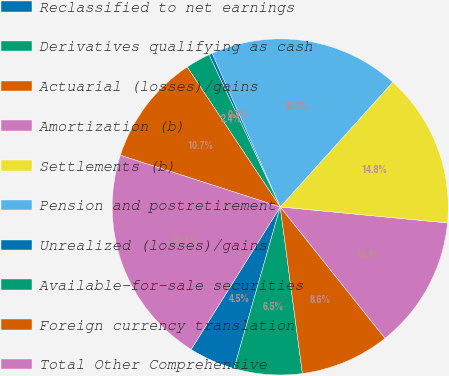Convert chart. <chart><loc_0><loc_0><loc_500><loc_500><pie_chart><fcel>Reclassified to net earnings<fcel>Derivatives qualifying as cash<fcel>Actuarial (losses)/gains<fcel>Amortization (b)<fcel>Settlements (b)<fcel>Pension and postretirement<fcel>Unrealized (losses)/gains<fcel>Available-for-sale securities<fcel>Foreign currency translation<fcel>Total Other Comprehensive<nl><fcel>4.46%<fcel>6.54%<fcel>8.61%<fcel>12.77%<fcel>14.84%<fcel>18.33%<fcel>0.31%<fcel>2.38%<fcel>10.69%<fcel>21.08%<nl></chart> 